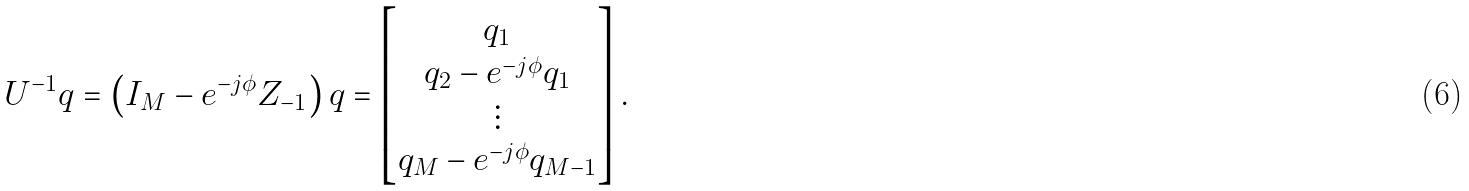<formula> <loc_0><loc_0><loc_500><loc_500>U ^ { - 1 } q = \left ( I _ { M } - e ^ { - j \phi } Z _ { - 1 } \right ) q = \begin{bmatrix} q _ { 1 } \\ q _ { 2 } - e ^ { - j \phi } q _ { 1 } \\ \vdots \\ q _ { M } - e ^ { - j \phi } q _ { M - 1 } \end{bmatrix} .</formula> 